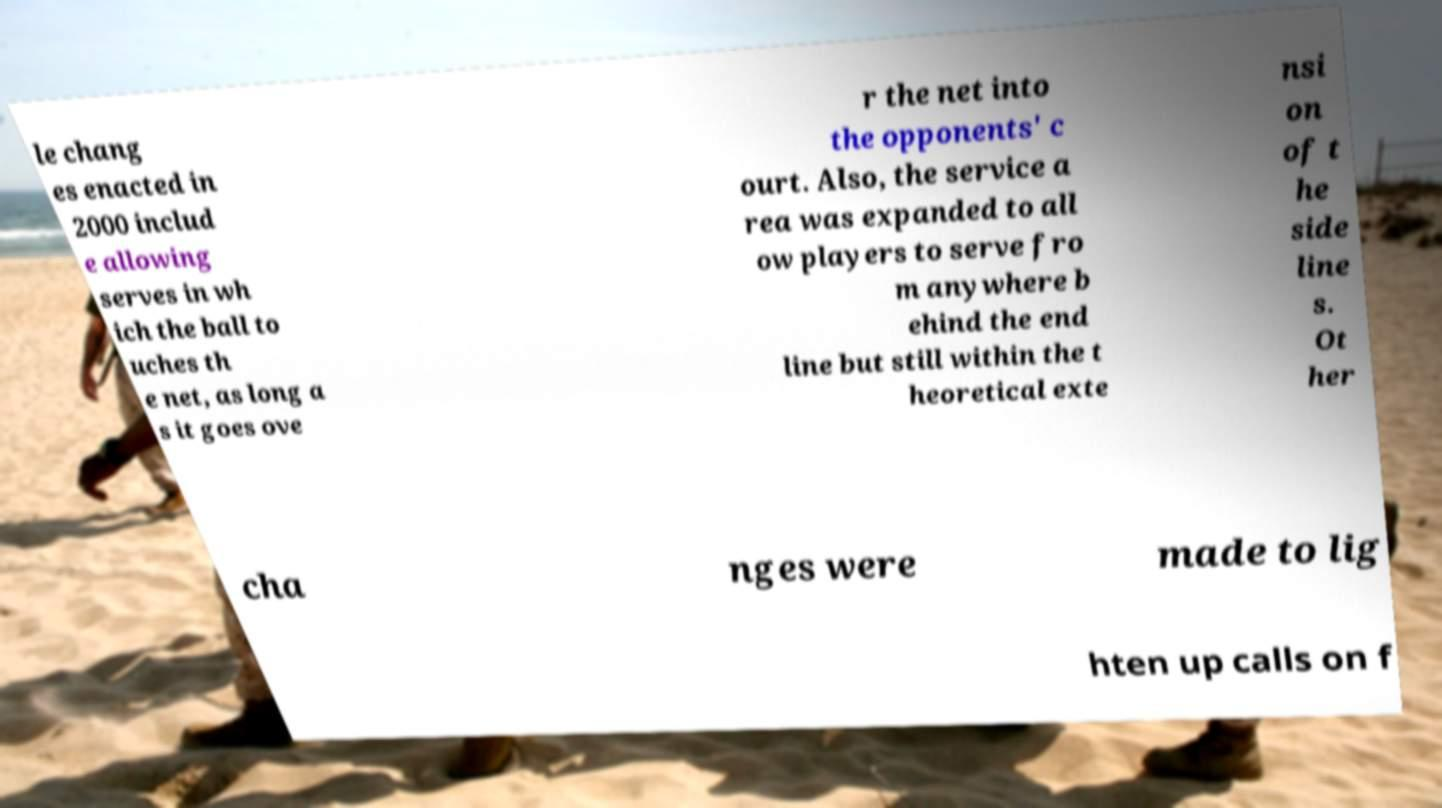Can you accurately transcribe the text from the provided image for me? le chang es enacted in 2000 includ e allowing serves in wh ich the ball to uches th e net, as long a s it goes ove r the net into the opponents' c ourt. Also, the service a rea was expanded to all ow players to serve fro m anywhere b ehind the end line but still within the t heoretical exte nsi on of t he side line s. Ot her cha nges were made to lig hten up calls on f 